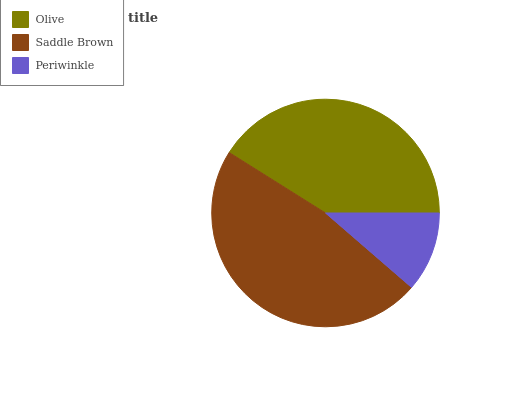Is Periwinkle the minimum?
Answer yes or no. Yes. Is Saddle Brown the maximum?
Answer yes or no. Yes. Is Saddle Brown the minimum?
Answer yes or no. No. Is Periwinkle the maximum?
Answer yes or no. No. Is Saddle Brown greater than Periwinkle?
Answer yes or no. Yes. Is Periwinkle less than Saddle Brown?
Answer yes or no. Yes. Is Periwinkle greater than Saddle Brown?
Answer yes or no. No. Is Saddle Brown less than Periwinkle?
Answer yes or no. No. Is Olive the high median?
Answer yes or no. Yes. Is Olive the low median?
Answer yes or no. Yes. Is Saddle Brown the high median?
Answer yes or no. No. Is Saddle Brown the low median?
Answer yes or no. No. 